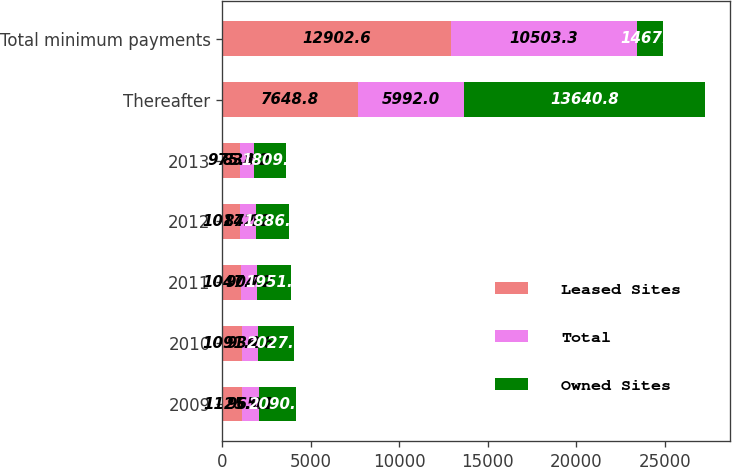Convert chart. <chart><loc_0><loc_0><loc_500><loc_500><stacked_bar_chart><ecel><fcel>2009<fcel>2010<fcel>2011<fcel>2012<fcel>2013<fcel>Thereafter<fcel>Total minimum payments<nl><fcel>Leased Sites<fcel>1125<fcel>1091.2<fcel>1047.7<fcel>1014.1<fcel>975.8<fcel>7648.8<fcel>12902.6<nl><fcel>Total<fcel>965.1<fcel>936.6<fcel>904.2<fcel>872.2<fcel>833.2<fcel>5992<fcel>10503.3<nl><fcel>Owned Sites<fcel>2090.1<fcel>2027.8<fcel>1951.9<fcel>1886.3<fcel>1809<fcel>13640.8<fcel>1467<nl></chart> 